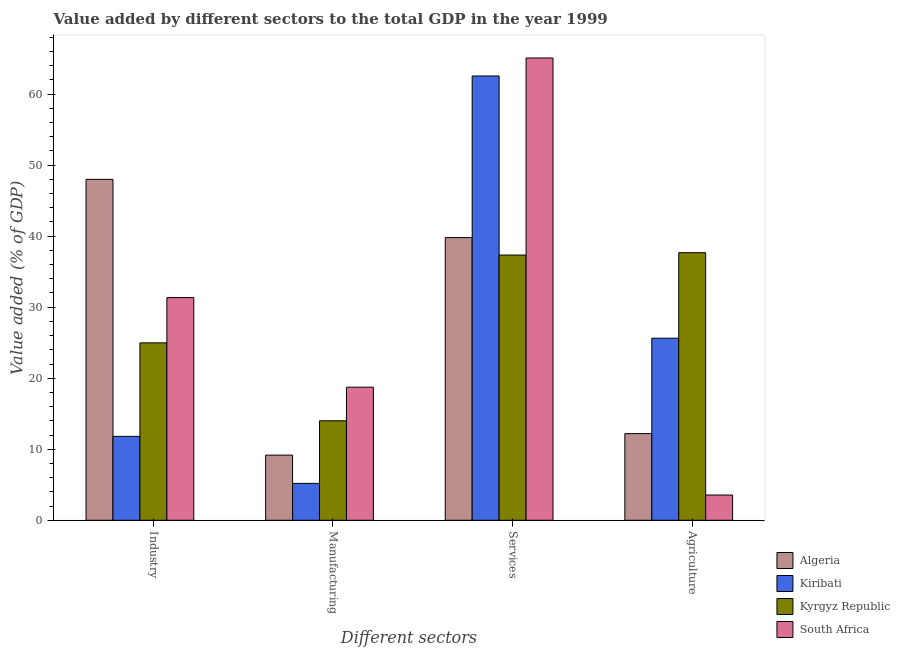How many bars are there on the 4th tick from the left?
Make the answer very short. 4. What is the label of the 3rd group of bars from the left?
Your answer should be very brief. Services. What is the value added by manufacturing sector in South Africa?
Offer a very short reply. 18.74. Across all countries, what is the maximum value added by manufacturing sector?
Your response must be concise. 18.74. Across all countries, what is the minimum value added by industrial sector?
Your answer should be very brief. 11.81. In which country was the value added by services sector maximum?
Ensure brevity in your answer.  South Africa. In which country was the value added by industrial sector minimum?
Offer a very short reply. Kiribati. What is the total value added by industrial sector in the graph?
Provide a succinct answer. 116.15. What is the difference between the value added by agricultural sector in South Africa and that in Algeria?
Your response must be concise. -8.64. What is the difference between the value added by agricultural sector in Algeria and the value added by manufacturing sector in Kiribati?
Provide a short and direct response. 7.01. What is the average value added by industrial sector per country?
Provide a succinct answer. 29.04. What is the difference between the value added by manufacturing sector and value added by services sector in Algeria?
Ensure brevity in your answer.  -30.63. What is the ratio of the value added by industrial sector in Algeria to that in Kyrgyz Republic?
Ensure brevity in your answer.  1.92. What is the difference between the highest and the second highest value added by services sector?
Keep it short and to the point. 2.53. What is the difference between the highest and the lowest value added by agricultural sector?
Your answer should be compact. 34.12. Is the sum of the value added by services sector in South Africa and Algeria greater than the maximum value added by manufacturing sector across all countries?
Offer a very short reply. Yes. Is it the case that in every country, the sum of the value added by industrial sector and value added by agricultural sector is greater than the sum of value added by services sector and value added by manufacturing sector?
Your response must be concise. No. What does the 2nd bar from the left in Industry represents?
Make the answer very short. Kiribati. What does the 4th bar from the right in Agriculture represents?
Ensure brevity in your answer.  Algeria. Are all the bars in the graph horizontal?
Offer a very short reply. No. Are the values on the major ticks of Y-axis written in scientific E-notation?
Ensure brevity in your answer.  No. How many legend labels are there?
Offer a very short reply. 4. How are the legend labels stacked?
Provide a short and direct response. Vertical. What is the title of the graph?
Your answer should be compact. Value added by different sectors to the total GDP in the year 1999. What is the label or title of the X-axis?
Offer a very short reply. Different sectors. What is the label or title of the Y-axis?
Give a very brief answer. Value added (% of GDP). What is the Value added (% of GDP) of Algeria in Industry?
Offer a very short reply. 48. What is the Value added (% of GDP) of Kiribati in Industry?
Give a very brief answer. 11.81. What is the Value added (% of GDP) of Kyrgyz Republic in Industry?
Provide a succinct answer. 24.98. What is the Value added (% of GDP) of South Africa in Industry?
Provide a short and direct response. 31.35. What is the Value added (% of GDP) in Algeria in Manufacturing?
Your answer should be very brief. 9.17. What is the Value added (% of GDP) of Kiribati in Manufacturing?
Make the answer very short. 5.19. What is the Value added (% of GDP) of Kyrgyz Republic in Manufacturing?
Make the answer very short. 14.01. What is the Value added (% of GDP) in South Africa in Manufacturing?
Keep it short and to the point. 18.74. What is the Value added (% of GDP) in Algeria in Services?
Give a very brief answer. 39.8. What is the Value added (% of GDP) of Kiribati in Services?
Provide a short and direct response. 62.55. What is the Value added (% of GDP) of Kyrgyz Republic in Services?
Your answer should be compact. 37.34. What is the Value added (% of GDP) of South Africa in Services?
Offer a terse response. 65.09. What is the Value added (% of GDP) of Algeria in Agriculture?
Your response must be concise. 12.2. What is the Value added (% of GDP) in Kiribati in Agriculture?
Your answer should be compact. 25.63. What is the Value added (% of GDP) of Kyrgyz Republic in Agriculture?
Offer a very short reply. 37.68. What is the Value added (% of GDP) in South Africa in Agriculture?
Provide a succinct answer. 3.56. Across all Different sectors, what is the maximum Value added (% of GDP) of Algeria?
Give a very brief answer. 48. Across all Different sectors, what is the maximum Value added (% of GDP) in Kiribati?
Offer a very short reply. 62.55. Across all Different sectors, what is the maximum Value added (% of GDP) in Kyrgyz Republic?
Offer a very short reply. 37.68. Across all Different sectors, what is the maximum Value added (% of GDP) in South Africa?
Provide a succinct answer. 65.09. Across all Different sectors, what is the minimum Value added (% of GDP) of Algeria?
Ensure brevity in your answer.  9.17. Across all Different sectors, what is the minimum Value added (% of GDP) of Kiribati?
Provide a short and direct response. 5.19. Across all Different sectors, what is the minimum Value added (% of GDP) of Kyrgyz Republic?
Provide a short and direct response. 14.01. Across all Different sectors, what is the minimum Value added (% of GDP) of South Africa?
Ensure brevity in your answer.  3.56. What is the total Value added (% of GDP) of Algeria in the graph?
Your response must be concise. 109.17. What is the total Value added (% of GDP) of Kiribati in the graph?
Offer a very short reply. 105.19. What is the total Value added (% of GDP) of Kyrgyz Republic in the graph?
Your answer should be compact. 114.01. What is the total Value added (% of GDP) in South Africa in the graph?
Offer a terse response. 118.74. What is the difference between the Value added (% of GDP) in Algeria in Industry and that in Manufacturing?
Give a very brief answer. 38.83. What is the difference between the Value added (% of GDP) in Kiribati in Industry and that in Manufacturing?
Your response must be concise. 6.62. What is the difference between the Value added (% of GDP) in Kyrgyz Republic in Industry and that in Manufacturing?
Provide a short and direct response. 10.97. What is the difference between the Value added (% of GDP) in South Africa in Industry and that in Manufacturing?
Provide a short and direct response. 12.62. What is the difference between the Value added (% of GDP) of Algeria in Industry and that in Services?
Provide a succinct answer. 8.2. What is the difference between the Value added (% of GDP) of Kiribati in Industry and that in Services?
Make the answer very short. -50.74. What is the difference between the Value added (% of GDP) of Kyrgyz Republic in Industry and that in Services?
Provide a succinct answer. -12.36. What is the difference between the Value added (% of GDP) of South Africa in Industry and that in Services?
Ensure brevity in your answer.  -33.73. What is the difference between the Value added (% of GDP) of Algeria in Industry and that in Agriculture?
Offer a terse response. 35.8. What is the difference between the Value added (% of GDP) in Kiribati in Industry and that in Agriculture?
Ensure brevity in your answer.  -13.82. What is the difference between the Value added (% of GDP) of Kyrgyz Republic in Industry and that in Agriculture?
Your response must be concise. -12.7. What is the difference between the Value added (% of GDP) of South Africa in Industry and that in Agriculture?
Provide a short and direct response. 27.8. What is the difference between the Value added (% of GDP) in Algeria in Manufacturing and that in Services?
Your response must be concise. -30.63. What is the difference between the Value added (% of GDP) in Kiribati in Manufacturing and that in Services?
Make the answer very short. -57.36. What is the difference between the Value added (% of GDP) in Kyrgyz Republic in Manufacturing and that in Services?
Give a very brief answer. -23.33. What is the difference between the Value added (% of GDP) in South Africa in Manufacturing and that in Services?
Your answer should be compact. -46.35. What is the difference between the Value added (% of GDP) in Algeria in Manufacturing and that in Agriculture?
Your answer should be very brief. -3.03. What is the difference between the Value added (% of GDP) of Kiribati in Manufacturing and that in Agriculture?
Your response must be concise. -20.44. What is the difference between the Value added (% of GDP) of Kyrgyz Republic in Manufacturing and that in Agriculture?
Offer a terse response. -23.67. What is the difference between the Value added (% of GDP) in South Africa in Manufacturing and that in Agriculture?
Give a very brief answer. 15.18. What is the difference between the Value added (% of GDP) of Algeria in Services and that in Agriculture?
Your answer should be very brief. 27.6. What is the difference between the Value added (% of GDP) of Kiribati in Services and that in Agriculture?
Your response must be concise. 36.92. What is the difference between the Value added (% of GDP) in Kyrgyz Republic in Services and that in Agriculture?
Keep it short and to the point. -0.34. What is the difference between the Value added (% of GDP) of South Africa in Services and that in Agriculture?
Offer a very short reply. 61.53. What is the difference between the Value added (% of GDP) in Algeria in Industry and the Value added (% of GDP) in Kiribati in Manufacturing?
Your answer should be very brief. 42.81. What is the difference between the Value added (% of GDP) in Algeria in Industry and the Value added (% of GDP) in Kyrgyz Republic in Manufacturing?
Keep it short and to the point. 33.99. What is the difference between the Value added (% of GDP) in Algeria in Industry and the Value added (% of GDP) in South Africa in Manufacturing?
Ensure brevity in your answer.  29.26. What is the difference between the Value added (% of GDP) in Kiribati in Industry and the Value added (% of GDP) in Kyrgyz Republic in Manufacturing?
Your response must be concise. -2.2. What is the difference between the Value added (% of GDP) of Kiribati in Industry and the Value added (% of GDP) of South Africa in Manufacturing?
Give a very brief answer. -6.93. What is the difference between the Value added (% of GDP) in Kyrgyz Republic in Industry and the Value added (% of GDP) in South Africa in Manufacturing?
Keep it short and to the point. 6.24. What is the difference between the Value added (% of GDP) in Algeria in Industry and the Value added (% of GDP) in Kiribati in Services?
Provide a short and direct response. -14.55. What is the difference between the Value added (% of GDP) of Algeria in Industry and the Value added (% of GDP) of Kyrgyz Republic in Services?
Give a very brief answer. 10.66. What is the difference between the Value added (% of GDP) of Algeria in Industry and the Value added (% of GDP) of South Africa in Services?
Offer a very short reply. -17.09. What is the difference between the Value added (% of GDP) in Kiribati in Industry and the Value added (% of GDP) in Kyrgyz Republic in Services?
Provide a short and direct response. -25.53. What is the difference between the Value added (% of GDP) of Kiribati in Industry and the Value added (% of GDP) of South Africa in Services?
Your response must be concise. -53.28. What is the difference between the Value added (% of GDP) of Kyrgyz Republic in Industry and the Value added (% of GDP) of South Africa in Services?
Ensure brevity in your answer.  -40.11. What is the difference between the Value added (% of GDP) in Algeria in Industry and the Value added (% of GDP) in Kiribati in Agriculture?
Keep it short and to the point. 22.37. What is the difference between the Value added (% of GDP) in Algeria in Industry and the Value added (% of GDP) in Kyrgyz Republic in Agriculture?
Give a very brief answer. 10.32. What is the difference between the Value added (% of GDP) in Algeria in Industry and the Value added (% of GDP) in South Africa in Agriculture?
Give a very brief answer. 44.44. What is the difference between the Value added (% of GDP) of Kiribati in Industry and the Value added (% of GDP) of Kyrgyz Republic in Agriculture?
Ensure brevity in your answer.  -25.87. What is the difference between the Value added (% of GDP) of Kiribati in Industry and the Value added (% of GDP) of South Africa in Agriculture?
Your response must be concise. 8.26. What is the difference between the Value added (% of GDP) of Kyrgyz Republic in Industry and the Value added (% of GDP) of South Africa in Agriculture?
Your response must be concise. 21.42. What is the difference between the Value added (% of GDP) in Algeria in Manufacturing and the Value added (% of GDP) in Kiribati in Services?
Your response must be concise. -53.38. What is the difference between the Value added (% of GDP) in Algeria in Manufacturing and the Value added (% of GDP) in Kyrgyz Republic in Services?
Give a very brief answer. -28.17. What is the difference between the Value added (% of GDP) in Algeria in Manufacturing and the Value added (% of GDP) in South Africa in Services?
Provide a short and direct response. -55.92. What is the difference between the Value added (% of GDP) of Kiribati in Manufacturing and the Value added (% of GDP) of Kyrgyz Republic in Services?
Keep it short and to the point. -32.15. What is the difference between the Value added (% of GDP) of Kiribati in Manufacturing and the Value added (% of GDP) of South Africa in Services?
Your answer should be very brief. -59.89. What is the difference between the Value added (% of GDP) in Kyrgyz Republic in Manufacturing and the Value added (% of GDP) in South Africa in Services?
Provide a short and direct response. -51.08. What is the difference between the Value added (% of GDP) of Algeria in Manufacturing and the Value added (% of GDP) of Kiribati in Agriculture?
Offer a very short reply. -16.46. What is the difference between the Value added (% of GDP) in Algeria in Manufacturing and the Value added (% of GDP) in Kyrgyz Republic in Agriculture?
Ensure brevity in your answer.  -28.51. What is the difference between the Value added (% of GDP) in Algeria in Manufacturing and the Value added (% of GDP) in South Africa in Agriculture?
Your answer should be compact. 5.62. What is the difference between the Value added (% of GDP) of Kiribati in Manufacturing and the Value added (% of GDP) of Kyrgyz Republic in Agriculture?
Make the answer very short. -32.48. What is the difference between the Value added (% of GDP) in Kiribati in Manufacturing and the Value added (% of GDP) in South Africa in Agriculture?
Your answer should be compact. 1.64. What is the difference between the Value added (% of GDP) in Kyrgyz Republic in Manufacturing and the Value added (% of GDP) in South Africa in Agriculture?
Keep it short and to the point. 10.45. What is the difference between the Value added (% of GDP) of Algeria in Services and the Value added (% of GDP) of Kiribati in Agriculture?
Your answer should be compact. 14.16. What is the difference between the Value added (% of GDP) in Algeria in Services and the Value added (% of GDP) in Kyrgyz Republic in Agriculture?
Your answer should be very brief. 2.12. What is the difference between the Value added (% of GDP) in Algeria in Services and the Value added (% of GDP) in South Africa in Agriculture?
Make the answer very short. 36.24. What is the difference between the Value added (% of GDP) in Kiribati in Services and the Value added (% of GDP) in Kyrgyz Republic in Agriculture?
Offer a very short reply. 24.87. What is the difference between the Value added (% of GDP) of Kiribati in Services and the Value added (% of GDP) of South Africa in Agriculture?
Your response must be concise. 59. What is the difference between the Value added (% of GDP) in Kyrgyz Republic in Services and the Value added (% of GDP) in South Africa in Agriculture?
Your answer should be very brief. 33.78. What is the average Value added (% of GDP) of Algeria per Different sectors?
Your answer should be very brief. 27.29. What is the average Value added (% of GDP) in Kiribati per Different sectors?
Make the answer very short. 26.3. What is the average Value added (% of GDP) of Kyrgyz Republic per Different sectors?
Keep it short and to the point. 28.5. What is the average Value added (% of GDP) of South Africa per Different sectors?
Offer a very short reply. 29.68. What is the difference between the Value added (% of GDP) in Algeria and Value added (% of GDP) in Kiribati in Industry?
Your response must be concise. 36.19. What is the difference between the Value added (% of GDP) of Algeria and Value added (% of GDP) of Kyrgyz Republic in Industry?
Provide a short and direct response. 23.02. What is the difference between the Value added (% of GDP) of Algeria and Value added (% of GDP) of South Africa in Industry?
Give a very brief answer. 16.65. What is the difference between the Value added (% of GDP) of Kiribati and Value added (% of GDP) of Kyrgyz Republic in Industry?
Give a very brief answer. -13.17. What is the difference between the Value added (% of GDP) of Kiribati and Value added (% of GDP) of South Africa in Industry?
Your answer should be compact. -19.54. What is the difference between the Value added (% of GDP) of Kyrgyz Republic and Value added (% of GDP) of South Africa in Industry?
Provide a short and direct response. -6.38. What is the difference between the Value added (% of GDP) in Algeria and Value added (% of GDP) in Kiribati in Manufacturing?
Ensure brevity in your answer.  3.98. What is the difference between the Value added (% of GDP) in Algeria and Value added (% of GDP) in Kyrgyz Republic in Manufacturing?
Provide a short and direct response. -4.84. What is the difference between the Value added (% of GDP) of Algeria and Value added (% of GDP) of South Africa in Manufacturing?
Give a very brief answer. -9.57. What is the difference between the Value added (% of GDP) of Kiribati and Value added (% of GDP) of Kyrgyz Republic in Manufacturing?
Your answer should be very brief. -8.81. What is the difference between the Value added (% of GDP) in Kiribati and Value added (% of GDP) in South Africa in Manufacturing?
Give a very brief answer. -13.54. What is the difference between the Value added (% of GDP) in Kyrgyz Republic and Value added (% of GDP) in South Africa in Manufacturing?
Offer a terse response. -4.73. What is the difference between the Value added (% of GDP) in Algeria and Value added (% of GDP) in Kiribati in Services?
Give a very brief answer. -22.76. What is the difference between the Value added (% of GDP) of Algeria and Value added (% of GDP) of Kyrgyz Republic in Services?
Provide a succinct answer. 2.46. What is the difference between the Value added (% of GDP) of Algeria and Value added (% of GDP) of South Africa in Services?
Give a very brief answer. -25.29. What is the difference between the Value added (% of GDP) in Kiribati and Value added (% of GDP) in Kyrgyz Republic in Services?
Give a very brief answer. 25.21. What is the difference between the Value added (% of GDP) of Kiribati and Value added (% of GDP) of South Africa in Services?
Provide a succinct answer. -2.53. What is the difference between the Value added (% of GDP) of Kyrgyz Republic and Value added (% of GDP) of South Africa in Services?
Keep it short and to the point. -27.75. What is the difference between the Value added (% of GDP) of Algeria and Value added (% of GDP) of Kiribati in Agriculture?
Give a very brief answer. -13.43. What is the difference between the Value added (% of GDP) of Algeria and Value added (% of GDP) of Kyrgyz Republic in Agriculture?
Your response must be concise. -25.48. What is the difference between the Value added (% of GDP) in Algeria and Value added (% of GDP) in South Africa in Agriculture?
Provide a short and direct response. 8.64. What is the difference between the Value added (% of GDP) of Kiribati and Value added (% of GDP) of Kyrgyz Republic in Agriculture?
Keep it short and to the point. -12.04. What is the difference between the Value added (% of GDP) in Kiribati and Value added (% of GDP) in South Africa in Agriculture?
Keep it short and to the point. 22.08. What is the difference between the Value added (% of GDP) in Kyrgyz Republic and Value added (% of GDP) in South Africa in Agriculture?
Make the answer very short. 34.12. What is the ratio of the Value added (% of GDP) in Algeria in Industry to that in Manufacturing?
Your response must be concise. 5.23. What is the ratio of the Value added (% of GDP) in Kiribati in Industry to that in Manufacturing?
Your answer should be compact. 2.27. What is the ratio of the Value added (% of GDP) of Kyrgyz Republic in Industry to that in Manufacturing?
Offer a terse response. 1.78. What is the ratio of the Value added (% of GDP) of South Africa in Industry to that in Manufacturing?
Provide a short and direct response. 1.67. What is the ratio of the Value added (% of GDP) of Algeria in Industry to that in Services?
Keep it short and to the point. 1.21. What is the ratio of the Value added (% of GDP) of Kiribati in Industry to that in Services?
Provide a succinct answer. 0.19. What is the ratio of the Value added (% of GDP) in Kyrgyz Republic in Industry to that in Services?
Your answer should be very brief. 0.67. What is the ratio of the Value added (% of GDP) of South Africa in Industry to that in Services?
Offer a very short reply. 0.48. What is the ratio of the Value added (% of GDP) in Algeria in Industry to that in Agriculture?
Your response must be concise. 3.93. What is the ratio of the Value added (% of GDP) in Kiribati in Industry to that in Agriculture?
Your answer should be compact. 0.46. What is the ratio of the Value added (% of GDP) in Kyrgyz Republic in Industry to that in Agriculture?
Ensure brevity in your answer.  0.66. What is the ratio of the Value added (% of GDP) in South Africa in Industry to that in Agriculture?
Provide a short and direct response. 8.82. What is the ratio of the Value added (% of GDP) in Algeria in Manufacturing to that in Services?
Your answer should be very brief. 0.23. What is the ratio of the Value added (% of GDP) in Kiribati in Manufacturing to that in Services?
Your answer should be very brief. 0.08. What is the ratio of the Value added (% of GDP) of Kyrgyz Republic in Manufacturing to that in Services?
Give a very brief answer. 0.38. What is the ratio of the Value added (% of GDP) in South Africa in Manufacturing to that in Services?
Ensure brevity in your answer.  0.29. What is the ratio of the Value added (% of GDP) of Algeria in Manufacturing to that in Agriculture?
Keep it short and to the point. 0.75. What is the ratio of the Value added (% of GDP) of Kiribati in Manufacturing to that in Agriculture?
Provide a succinct answer. 0.2. What is the ratio of the Value added (% of GDP) of Kyrgyz Republic in Manufacturing to that in Agriculture?
Your answer should be very brief. 0.37. What is the ratio of the Value added (% of GDP) in South Africa in Manufacturing to that in Agriculture?
Your answer should be compact. 5.27. What is the ratio of the Value added (% of GDP) of Algeria in Services to that in Agriculture?
Ensure brevity in your answer.  3.26. What is the ratio of the Value added (% of GDP) of Kiribati in Services to that in Agriculture?
Provide a short and direct response. 2.44. What is the ratio of the Value added (% of GDP) in South Africa in Services to that in Agriculture?
Make the answer very short. 18.3. What is the difference between the highest and the second highest Value added (% of GDP) of Algeria?
Keep it short and to the point. 8.2. What is the difference between the highest and the second highest Value added (% of GDP) in Kiribati?
Your answer should be compact. 36.92. What is the difference between the highest and the second highest Value added (% of GDP) of Kyrgyz Republic?
Offer a terse response. 0.34. What is the difference between the highest and the second highest Value added (% of GDP) of South Africa?
Offer a terse response. 33.73. What is the difference between the highest and the lowest Value added (% of GDP) of Algeria?
Give a very brief answer. 38.83. What is the difference between the highest and the lowest Value added (% of GDP) of Kiribati?
Provide a succinct answer. 57.36. What is the difference between the highest and the lowest Value added (% of GDP) of Kyrgyz Republic?
Keep it short and to the point. 23.67. What is the difference between the highest and the lowest Value added (% of GDP) in South Africa?
Ensure brevity in your answer.  61.53. 